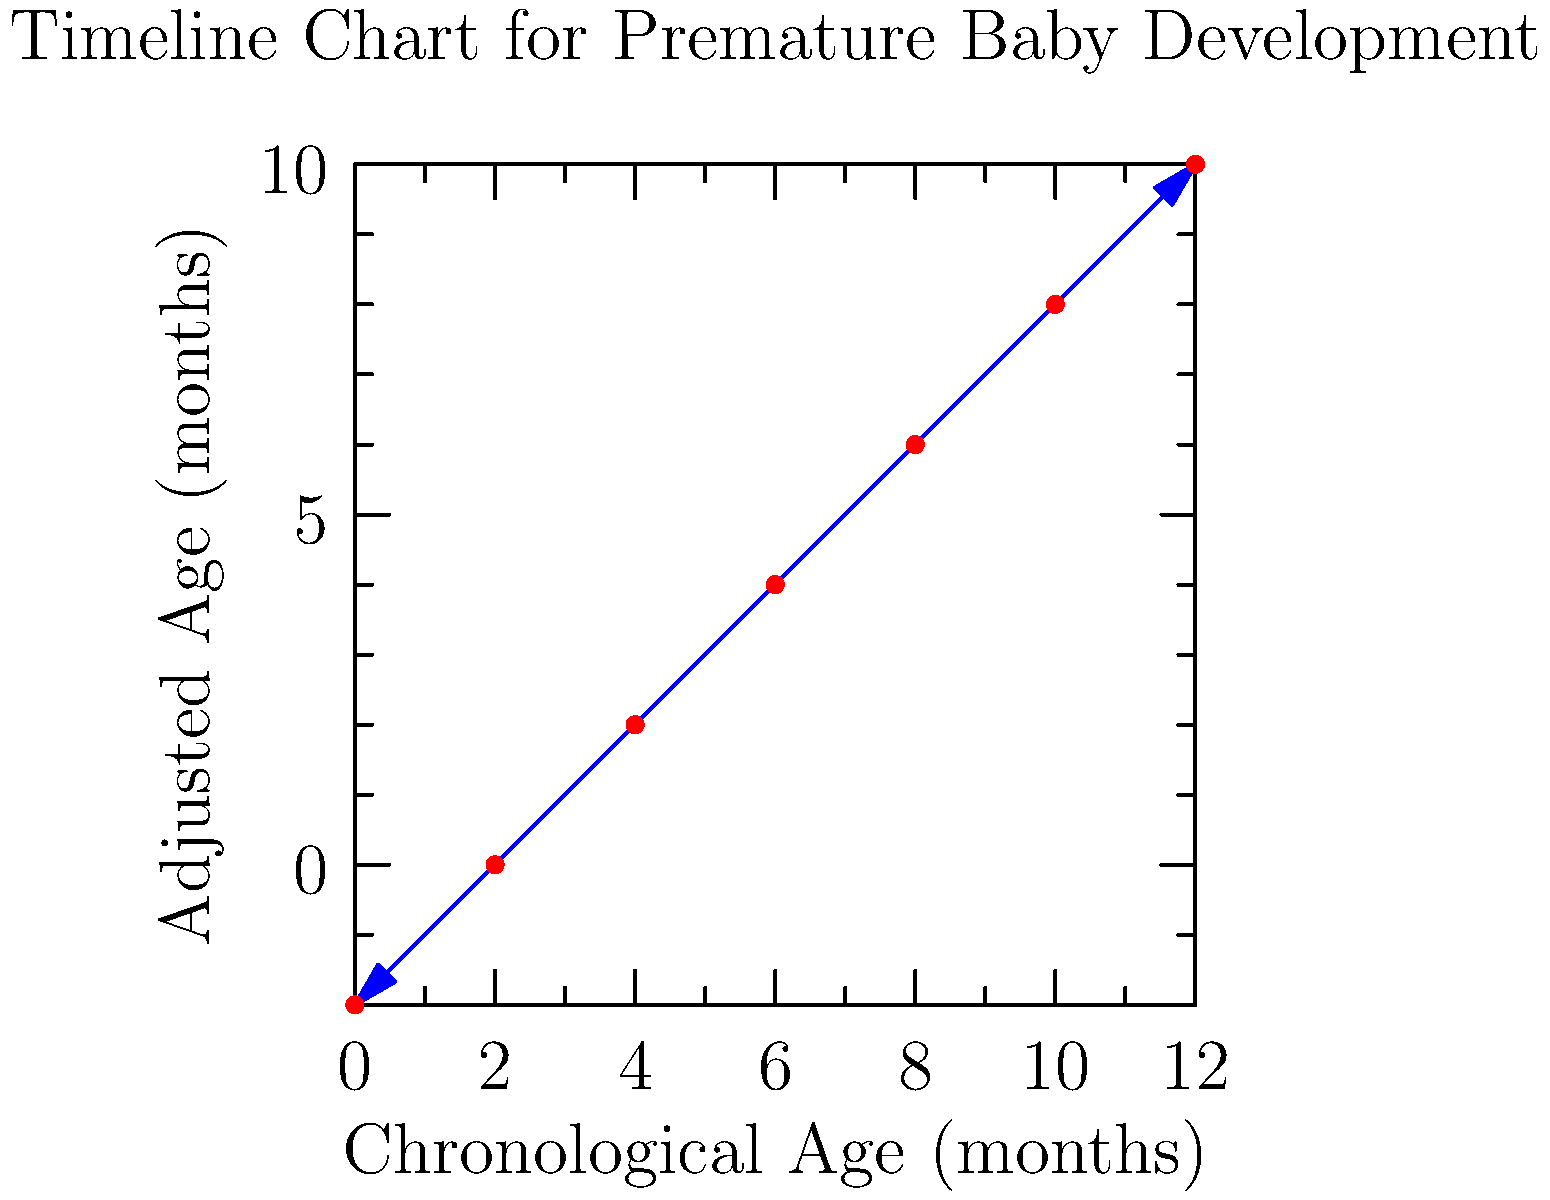Based on the timeline chart for premature baby development, at what chronological age (in months) does the adjusted age become positive? To answer this question, we need to analyze the timeline chart step-by-step:

1. The x-axis represents the chronological age in months, starting from 0 to 12 months.
2. The y-axis represents the adjusted age in months, ranging from -2 to 10 months.
3. The blue line represents the relationship between chronological age and adjusted age for a premature baby.
4. We need to find the point where the blue line crosses the x-axis, as this is where the adjusted age becomes positive (greater than 0).
5. By examining the chart, we can see that the line crosses the x-axis between 2 and 4 months of chronological age.
6. More precisely, we can estimate that the crossing point occurs at approximately 3 months of chronological age.

Therefore, the adjusted age becomes positive when the chronological age is around 3 months.
Answer: 3 months 